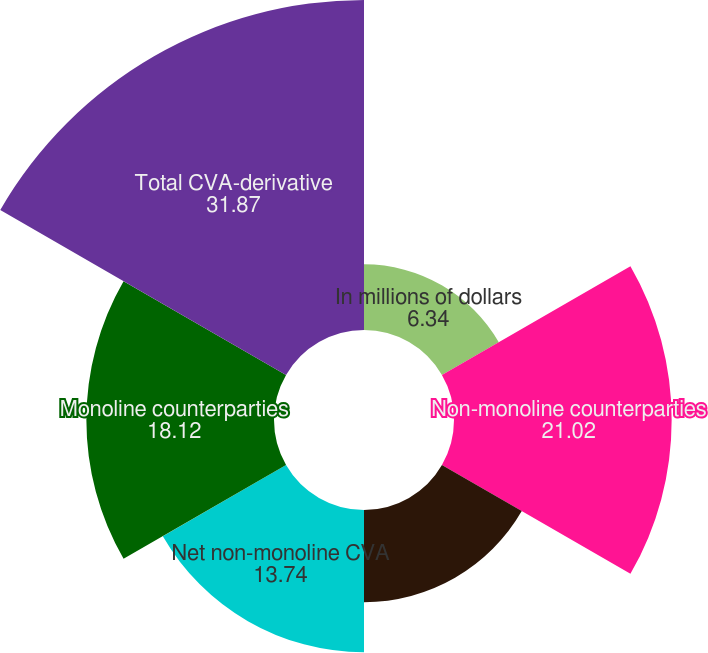Convert chart. <chart><loc_0><loc_0><loc_500><loc_500><pie_chart><fcel>In millions of dollars<fcel>Non-monoline counterparties<fcel>Citigroup (own)<fcel>Net non-monoline CVA<fcel>Monoline counterparties<fcel>Total CVA-derivative<nl><fcel>6.34%<fcel>21.02%<fcel>8.9%<fcel>13.74%<fcel>18.12%<fcel>31.87%<nl></chart> 